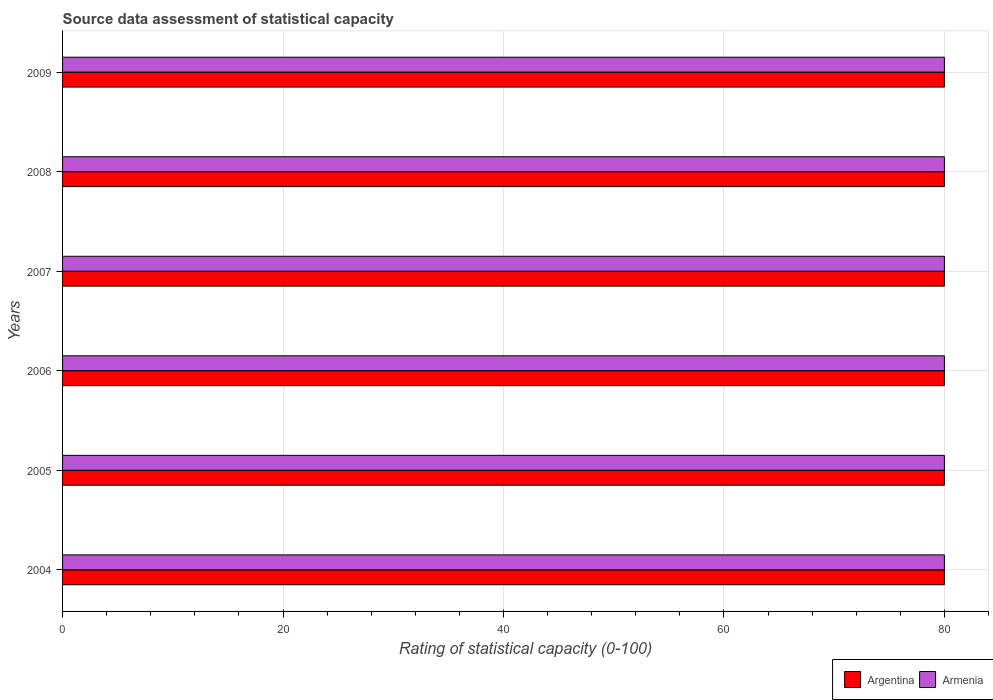How many different coloured bars are there?
Your answer should be very brief. 2. How many groups of bars are there?
Keep it short and to the point. 6. Are the number of bars per tick equal to the number of legend labels?
Ensure brevity in your answer.  Yes. How many bars are there on the 5th tick from the bottom?
Ensure brevity in your answer.  2. What is the rating of statistical capacity in Armenia in 2006?
Your answer should be compact. 80. Across all years, what is the maximum rating of statistical capacity in Argentina?
Ensure brevity in your answer.  80. Across all years, what is the minimum rating of statistical capacity in Armenia?
Provide a short and direct response. 80. What is the total rating of statistical capacity in Argentina in the graph?
Keep it short and to the point. 480. What is the difference between the rating of statistical capacity in Armenia in 2005 and that in 2007?
Your answer should be compact. 0. What is the average rating of statistical capacity in Argentina per year?
Offer a terse response. 80. In the year 2009, what is the difference between the rating of statistical capacity in Armenia and rating of statistical capacity in Argentina?
Your answer should be very brief. 0. Is the difference between the rating of statistical capacity in Armenia in 2005 and 2008 greater than the difference between the rating of statistical capacity in Argentina in 2005 and 2008?
Offer a terse response. No. What is the difference between the highest and the second highest rating of statistical capacity in Armenia?
Offer a very short reply. 0. Is the sum of the rating of statistical capacity in Armenia in 2006 and 2008 greater than the maximum rating of statistical capacity in Argentina across all years?
Ensure brevity in your answer.  Yes. What does the 1st bar from the top in 2006 represents?
Your response must be concise. Armenia. What does the 2nd bar from the bottom in 2007 represents?
Provide a short and direct response. Armenia. Are all the bars in the graph horizontal?
Give a very brief answer. Yes. Are the values on the major ticks of X-axis written in scientific E-notation?
Provide a succinct answer. No. Does the graph contain grids?
Ensure brevity in your answer.  Yes. What is the title of the graph?
Make the answer very short. Source data assessment of statistical capacity. What is the label or title of the X-axis?
Provide a short and direct response. Rating of statistical capacity (0-100). What is the label or title of the Y-axis?
Give a very brief answer. Years. What is the Rating of statistical capacity (0-100) of Argentina in 2004?
Make the answer very short. 80. What is the Rating of statistical capacity (0-100) in Armenia in 2004?
Ensure brevity in your answer.  80. What is the Rating of statistical capacity (0-100) in Argentina in 2005?
Ensure brevity in your answer.  80. What is the Rating of statistical capacity (0-100) of Armenia in 2005?
Your answer should be very brief. 80. What is the Rating of statistical capacity (0-100) of Armenia in 2006?
Provide a succinct answer. 80. What is the Rating of statistical capacity (0-100) in Argentina in 2007?
Ensure brevity in your answer.  80. What is the Rating of statistical capacity (0-100) of Armenia in 2008?
Your answer should be very brief. 80. What is the Rating of statistical capacity (0-100) of Argentina in 2009?
Your response must be concise. 80. Across all years, what is the minimum Rating of statistical capacity (0-100) of Argentina?
Your answer should be very brief. 80. What is the total Rating of statistical capacity (0-100) in Argentina in the graph?
Keep it short and to the point. 480. What is the total Rating of statistical capacity (0-100) in Armenia in the graph?
Make the answer very short. 480. What is the difference between the Rating of statistical capacity (0-100) of Argentina in 2004 and that in 2005?
Your answer should be very brief. 0. What is the difference between the Rating of statistical capacity (0-100) in Armenia in 2004 and that in 2005?
Keep it short and to the point. 0. What is the difference between the Rating of statistical capacity (0-100) of Argentina in 2004 and that in 2006?
Your answer should be compact. 0. What is the difference between the Rating of statistical capacity (0-100) in Armenia in 2004 and that in 2006?
Your response must be concise. 0. What is the difference between the Rating of statistical capacity (0-100) in Argentina in 2004 and that in 2007?
Make the answer very short. 0. What is the difference between the Rating of statistical capacity (0-100) in Armenia in 2004 and that in 2007?
Provide a succinct answer. 0. What is the difference between the Rating of statistical capacity (0-100) of Argentina in 2005 and that in 2007?
Make the answer very short. 0. What is the difference between the Rating of statistical capacity (0-100) of Argentina in 2005 and that in 2008?
Give a very brief answer. 0. What is the difference between the Rating of statistical capacity (0-100) of Argentina in 2005 and that in 2009?
Your response must be concise. 0. What is the difference between the Rating of statistical capacity (0-100) of Armenia in 2005 and that in 2009?
Offer a terse response. 0. What is the difference between the Rating of statistical capacity (0-100) of Armenia in 2006 and that in 2007?
Your response must be concise. 0. What is the difference between the Rating of statistical capacity (0-100) in Armenia in 2006 and that in 2009?
Your response must be concise. 0. What is the difference between the Rating of statistical capacity (0-100) in Argentina in 2005 and the Rating of statistical capacity (0-100) in Armenia in 2007?
Offer a very short reply. 0. What is the difference between the Rating of statistical capacity (0-100) in Argentina in 2005 and the Rating of statistical capacity (0-100) in Armenia in 2008?
Give a very brief answer. 0. What is the difference between the Rating of statistical capacity (0-100) in Argentina in 2005 and the Rating of statistical capacity (0-100) in Armenia in 2009?
Your answer should be very brief. 0. What is the difference between the Rating of statistical capacity (0-100) of Argentina in 2006 and the Rating of statistical capacity (0-100) of Armenia in 2007?
Provide a short and direct response. 0. What is the difference between the Rating of statistical capacity (0-100) of Argentina in 2006 and the Rating of statistical capacity (0-100) of Armenia in 2009?
Offer a terse response. 0. What is the difference between the Rating of statistical capacity (0-100) in Argentina in 2007 and the Rating of statistical capacity (0-100) in Armenia in 2008?
Keep it short and to the point. 0. What is the difference between the Rating of statistical capacity (0-100) of Argentina in 2008 and the Rating of statistical capacity (0-100) of Armenia in 2009?
Give a very brief answer. 0. What is the average Rating of statistical capacity (0-100) in Armenia per year?
Provide a succinct answer. 80. In the year 2004, what is the difference between the Rating of statistical capacity (0-100) in Argentina and Rating of statistical capacity (0-100) in Armenia?
Provide a succinct answer. 0. In the year 2006, what is the difference between the Rating of statistical capacity (0-100) of Argentina and Rating of statistical capacity (0-100) of Armenia?
Offer a terse response. 0. What is the ratio of the Rating of statistical capacity (0-100) of Argentina in 2004 to that in 2005?
Ensure brevity in your answer.  1. What is the ratio of the Rating of statistical capacity (0-100) of Armenia in 2004 to that in 2005?
Offer a terse response. 1. What is the ratio of the Rating of statistical capacity (0-100) in Argentina in 2004 to that in 2006?
Offer a terse response. 1. What is the ratio of the Rating of statistical capacity (0-100) of Armenia in 2004 to that in 2007?
Keep it short and to the point. 1. What is the ratio of the Rating of statistical capacity (0-100) of Armenia in 2004 to that in 2008?
Provide a short and direct response. 1. What is the ratio of the Rating of statistical capacity (0-100) of Argentina in 2004 to that in 2009?
Your answer should be compact. 1. What is the ratio of the Rating of statistical capacity (0-100) in Armenia in 2005 to that in 2006?
Your answer should be compact. 1. What is the ratio of the Rating of statistical capacity (0-100) of Armenia in 2005 to that in 2007?
Your response must be concise. 1. What is the ratio of the Rating of statistical capacity (0-100) in Armenia in 2005 to that in 2008?
Provide a short and direct response. 1. What is the ratio of the Rating of statistical capacity (0-100) in Argentina in 2006 to that in 2008?
Your answer should be compact. 1. What is the ratio of the Rating of statistical capacity (0-100) in Armenia in 2007 to that in 2008?
Offer a very short reply. 1. What is the ratio of the Rating of statistical capacity (0-100) of Argentina in 2007 to that in 2009?
Your response must be concise. 1. What is the ratio of the Rating of statistical capacity (0-100) of Armenia in 2007 to that in 2009?
Your answer should be very brief. 1. What is the ratio of the Rating of statistical capacity (0-100) of Armenia in 2008 to that in 2009?
Give a very brief answer. 1. What is the difference between the highest and the second highest Rating of statistical capacity (0-100) in Argentina?
Your answer should be very brief. 0. What is the difference between the highest and the second highest Rating of statistical capacity (0-100) of Armenia?
Ensure brevity in your answer.  0. 